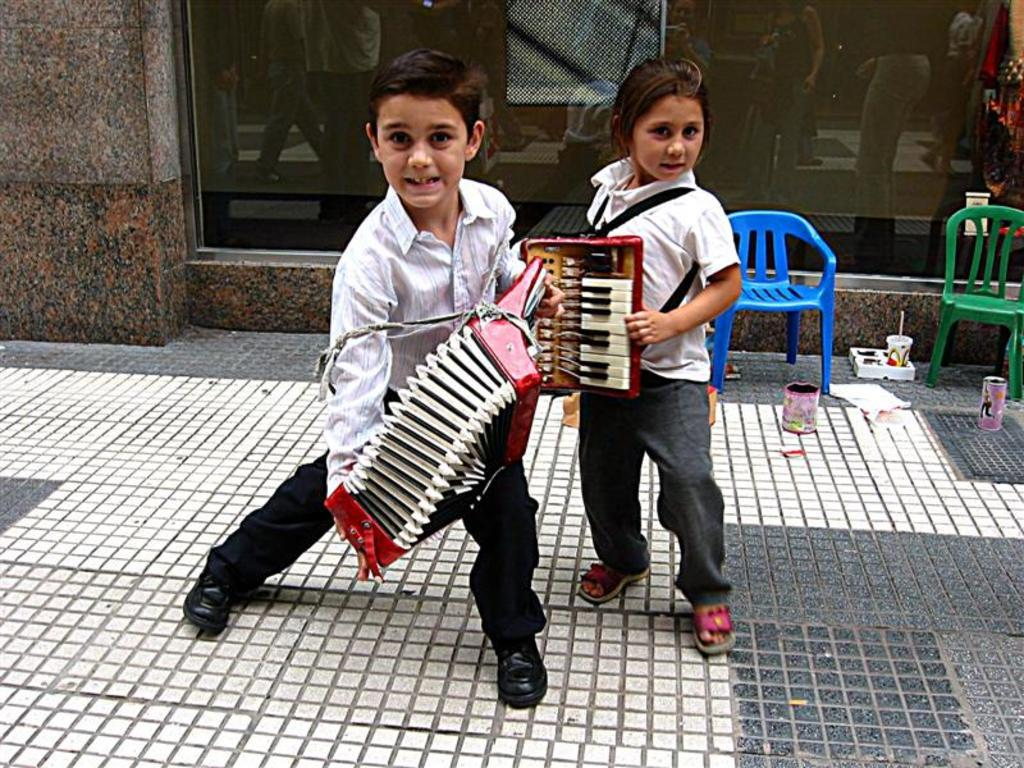Who are the people in the image? There is a boy and a girl in the image. What is the girl doing in the image? The girl is playing a musical instrument. What can be seen on the left side of the image? There are two chairs on the left side of the image. What else is present on the ground in the image? There is other stuff on the ground in the image. What type of territory is being claimed by the boy in the image? There is no indication in the image that the boy is claiming any territory. 